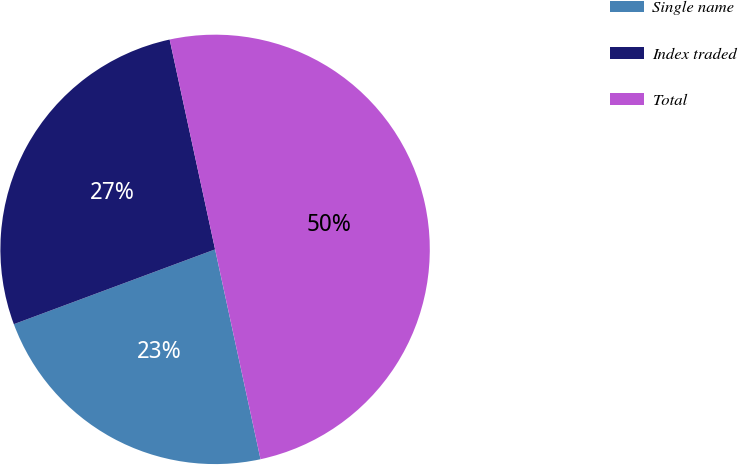Convert chart to OTSL. <chart><loc_0><loc_0><loc_500><loc_500><pie_chart><fcel>Single name<fcel>Index traded<fcel>Total<nl><fcel>22.73%<fcel>27.27%<fcel>50.0%<nl></chart> 